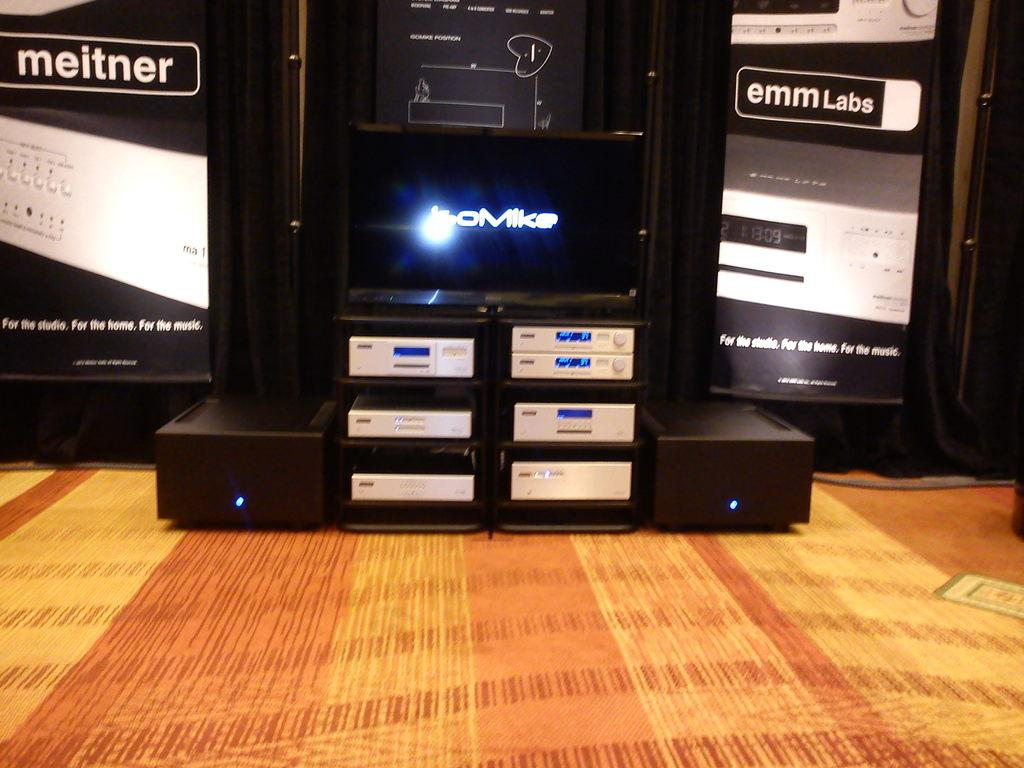<image>
Summarize the visual content of the image. Items from meitner an emmlabs are sitting near each other. 